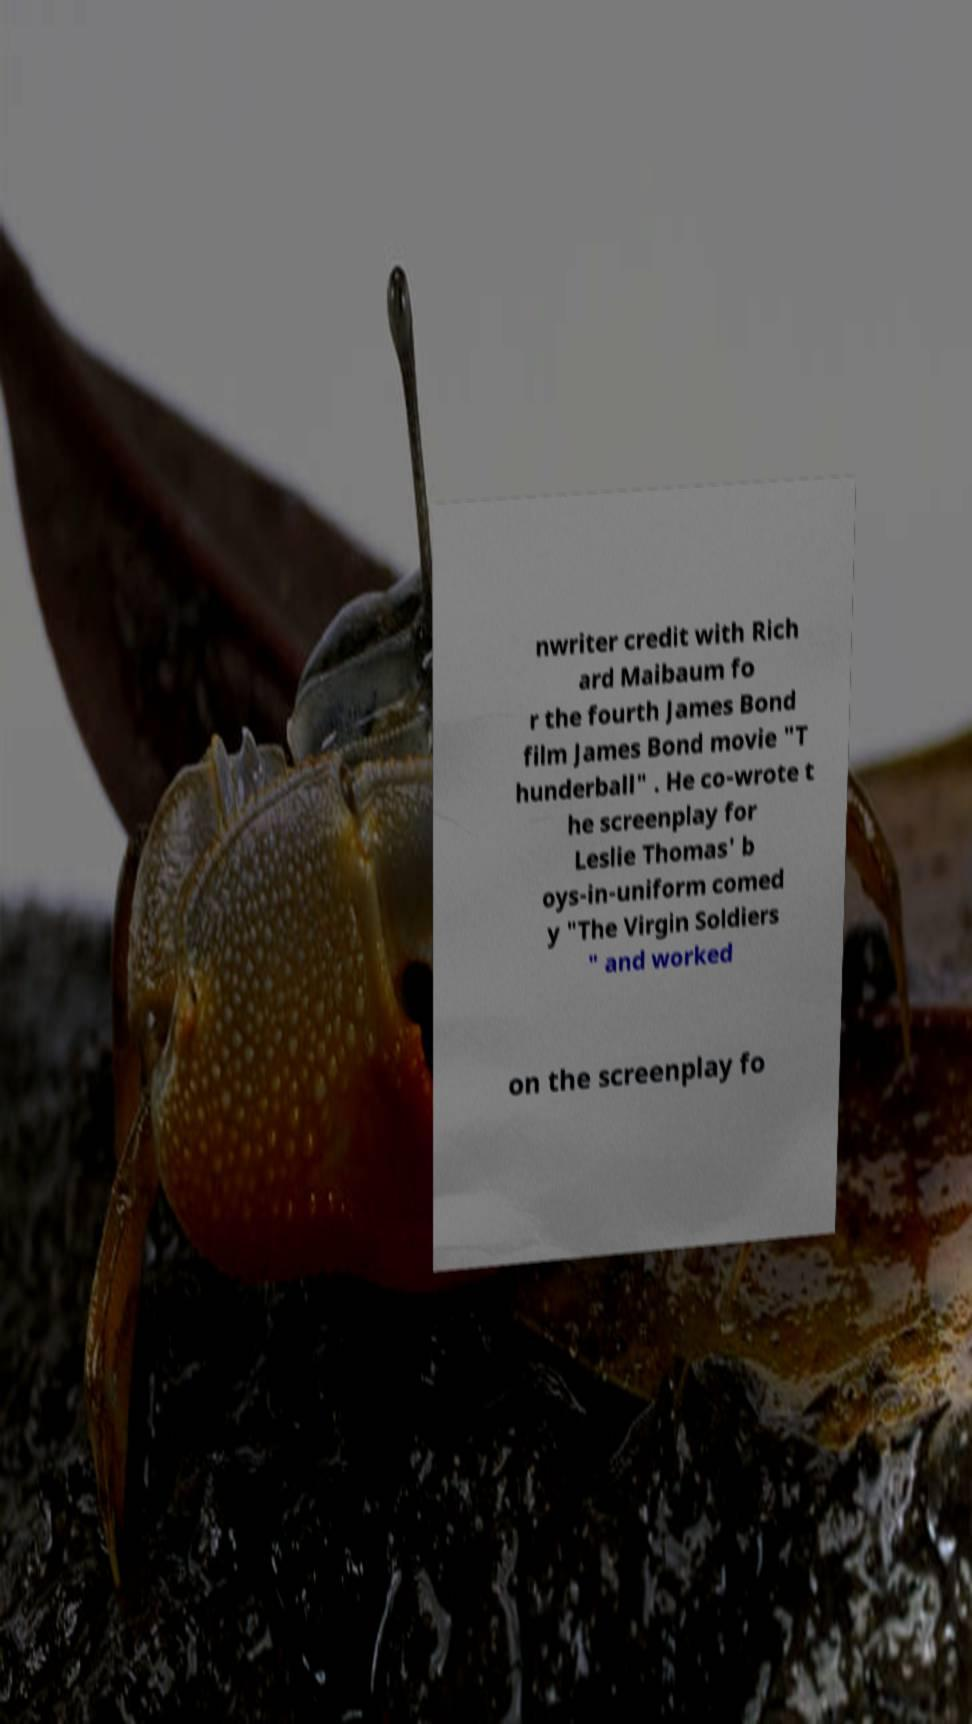Can you read and provide the text displayed in the image?This photo seems to have some interesting text. Can you extract and type it out for me? nwriter credit with Rich ard Maibaum fo r the fourth James Bond film James Bond movie "T hunderball" . He co-wrote t he screenplay for Leslie Thomas' b oys-in-uniform comed y "The Virgin Soldiers " and worked on the screenplay fo 